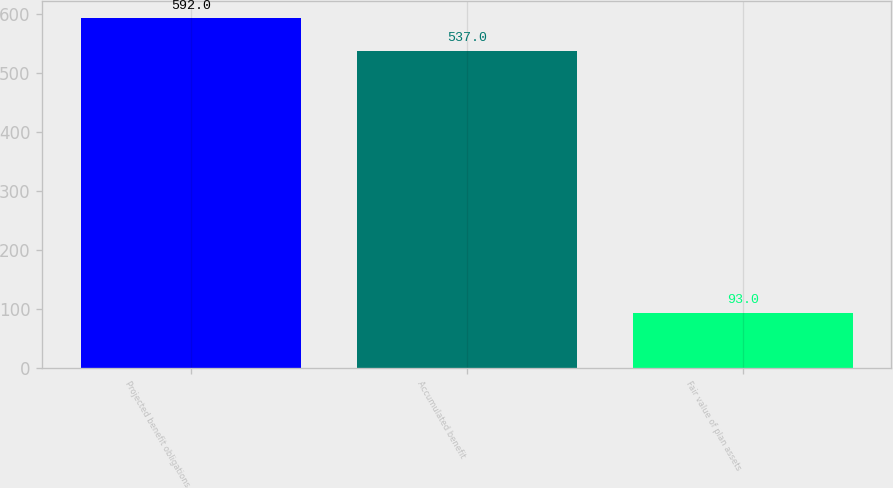Convert chart. <chart><loc_0><loc_0><loc_500><loc_500><bar_chart><fcel>Projected benefit obligations<fcel>Accumulated benefit<fcel>Fair value of plan assets<nl><fcel>592<fcel>537<fcel>93<nl></chart> 